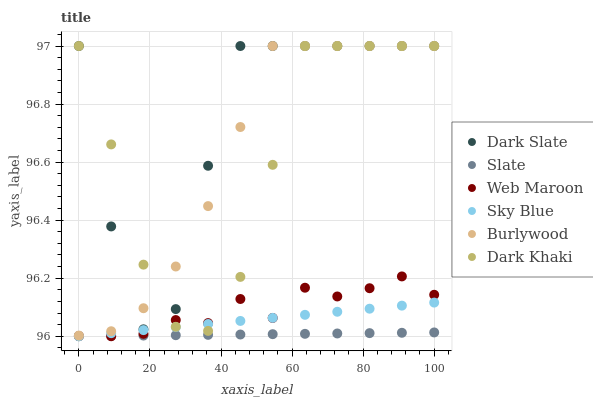Does Slate have the minimum area under the curve?
Answer yes or no. Yes. Does Dark Slate have the maximum area under the curve?
Answer yes or no. Yes. Does Web Maroon have the minimum area under the curve?
Answer yes or no. No. Does Web Maroon have the maximum area under the curve?
Answer yes or no. No. Is Sky Blue the smoothest?
Answer yes or no. Yes. Is Dark Slate the roughest?
Answer yes or no. Yes. Is Slate the smoothest?
Answer yes or no. No. Is Slate the roughest?
Answer yes or no. No. Does Slate have the lowest value?
Answer yes or no. Yes. Does Dark Khaki have the lowest value?
Answer yes or no. No. Does Dark Slate have the highest value?
Answer yes or no. Yes. Does Web Maroon have the highest value?
Answer yes or no. No. Is Web Maroon less than Burlywood?
Answer yes or no. Yes. Is Burlywood greater than Sky Blue?
Answer yes or no. Yes. Does Burlywood intersect Dark Khaki?
Answer yes or no. Yes. Is Burlywood less than Dark Khaki?
Answer yes or no. No. Is Burlywood greater than Dark Khaki?
Answer yes or no. No. Does Web Maroon intersect Burlywood?
Answer yes or no. No. 